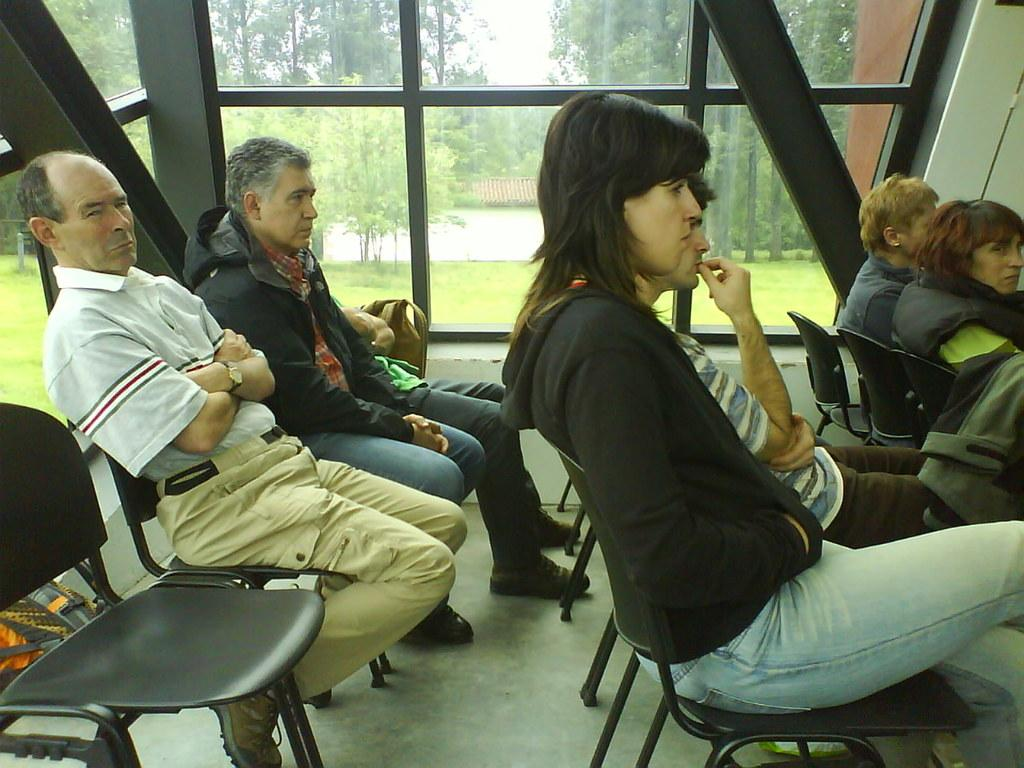What are the people in the image doing? The people in the image are sitting on chairs. What is the purpose of the glass window in the image? The glass window allows the sky, trees, and grass to be visible in the image. Can you describe the view through the glass window? The sky, trees, and grass are visible through the glass window. What type of hose is being used to fan the grass in the image? There is no hose or fan present in the image; it only shows people sitting on chairs and a view through a glass window. 